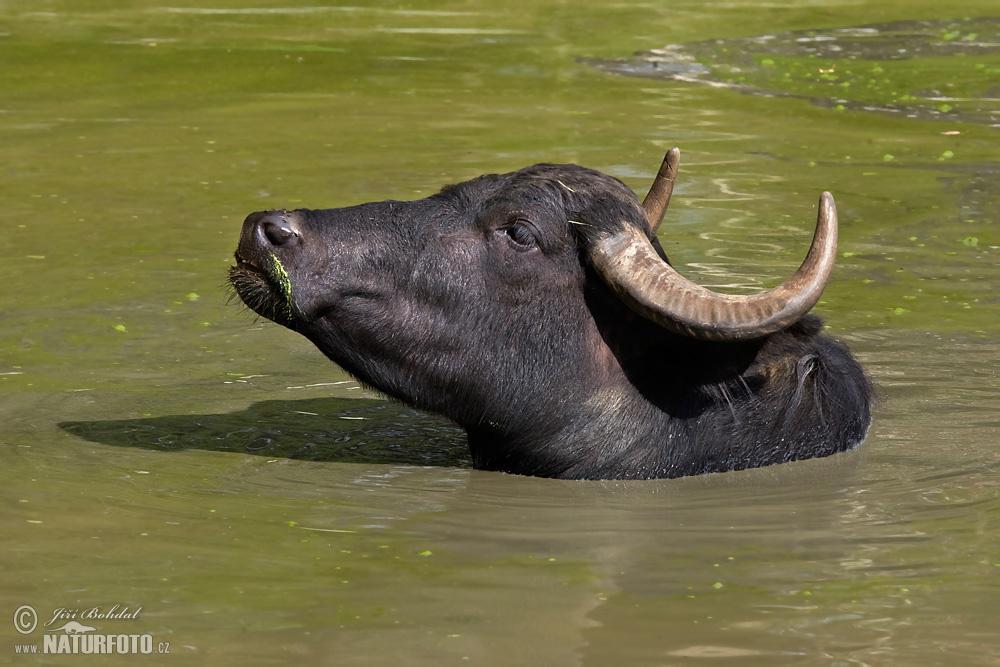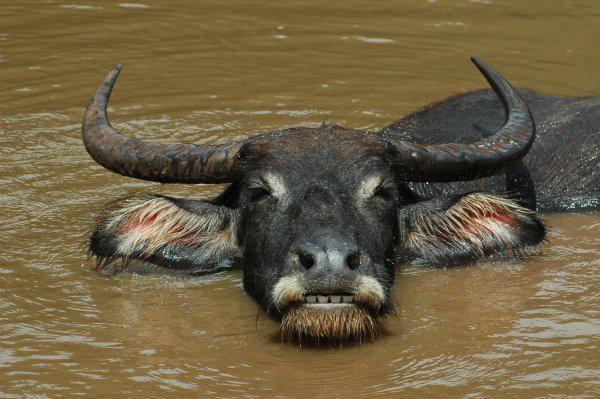The first image is the image on the left, the second image is the image on the right. Examine the images to the left and right. Is the description "There is at least one human child in one of the images." accurate? Answer yes or no. No. The first image is the image on the left, the second image is the image on the right. Examine the images to the left and right. Is the description "At least one young boy is in the water near a water buffalo in one image." accurate? Answer yes or no. No. 